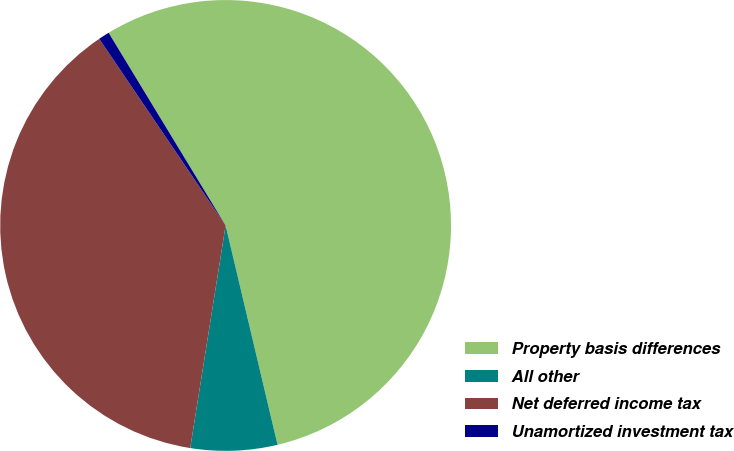Convert chart to OTSL. <chart><loc_0><loc_0><loc_500><loc_500><pie_chart><fcel>Property basis differences<fcel>All other<fcel>Net deferred income tax<fcel>Unamortized investment tax<nl><fcel>54.99%<fcel>6.21%<fcel>38.02%<fcel>0.79%<nl></chart> 